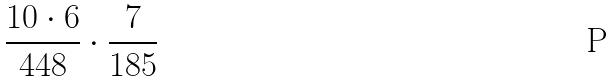<formula> <loc_0><loc_0><loc_500><loc_500>\frac { 1 0 \cdot 6 } { 4 4 8 } \cdot \frac { 7 } { 1 8 5 }</formula> 